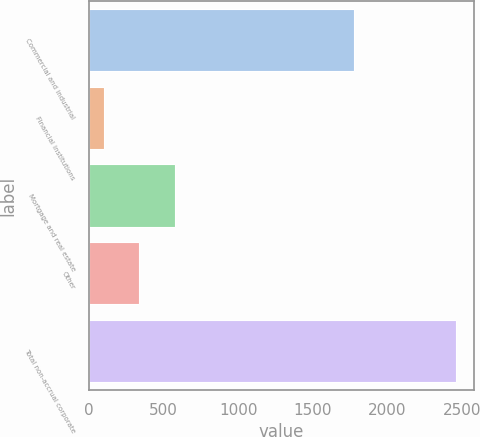Convert chart. <chart><loc_0><loc_0><loc_500><loc_500><bar_chart><fcel>Commercial and industrial<fcel>Financial institutions<fcel>Mortgage and real estate<fcel>Other<fcel>Total non-accrual corporate<nl><fcel>1775<fcel>102<fcel>573.4<fcel>337.7<fcel>2459<nl></chart> 